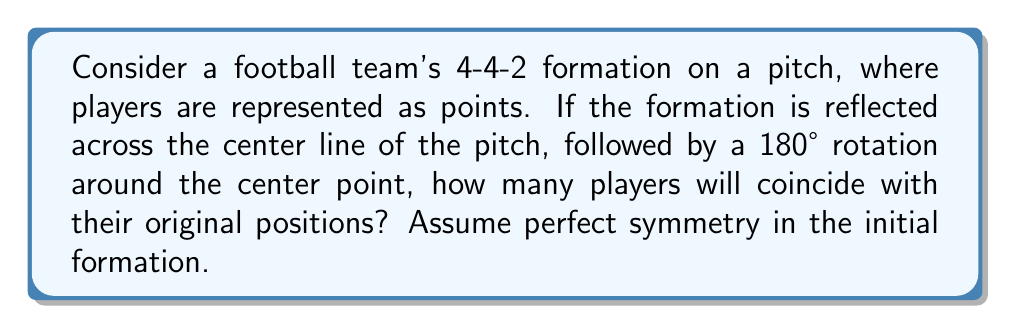Can you answer this question? Let's approach this step-by-step:

1) First, let's visualize the 4-4-2 formation:

[asy]
unitsize(1cm);
import geometry;

// Draw the pitch
draw((-5,-3)--(5,-3)--(5,3)--(-5,3)--cycle);
draw((0,-3)--(0,3));

// Draw the players
dot((0,2.5)); dot((0,-2.5)); // Forwards
dot((-2,1)); dot((-2,-1)); dot((2,1)); dot((2,-1)); // Midfielders
dot((-4,1.5)); dot((-4,-1.5)); dot((4,1.5)); dot((4,-1.5)); // Defenders

label("GK", (-4.5,0));
[/asy]

2) The transformation can be described mathematically as:
   $T = R_{180°} \circ M_y$
   where $M_y$ is reflection across the y-axis (center line) and $R_{180°}$ is rotation by 180°.

3) Let's consider the effect of this transformation on each line of players:

   - Goalkeeper (GK): Reflected to (4.5,0), then rotated to (-4.5,0). Coincides.
   - Defenders: Reflected to (±4, ±1.5), then rotated to (∓4, ∓1.5). Coincide.
   - Midfielders: Reflected to (±2, ±1), then rotated to (∓2, ∓1). Coincide.
   - Forwards: Reflected to (0, ±2.5), then rotated to (0, ∓2.5). Do not coincide.

4) Counting the coinciding players:
   1 (GK) + 4 (Defenders) + 4 (Midfielders) = 9 players

Therefore, 9 players will coincide with their original positions after the transformation.
Answer: 9 players 